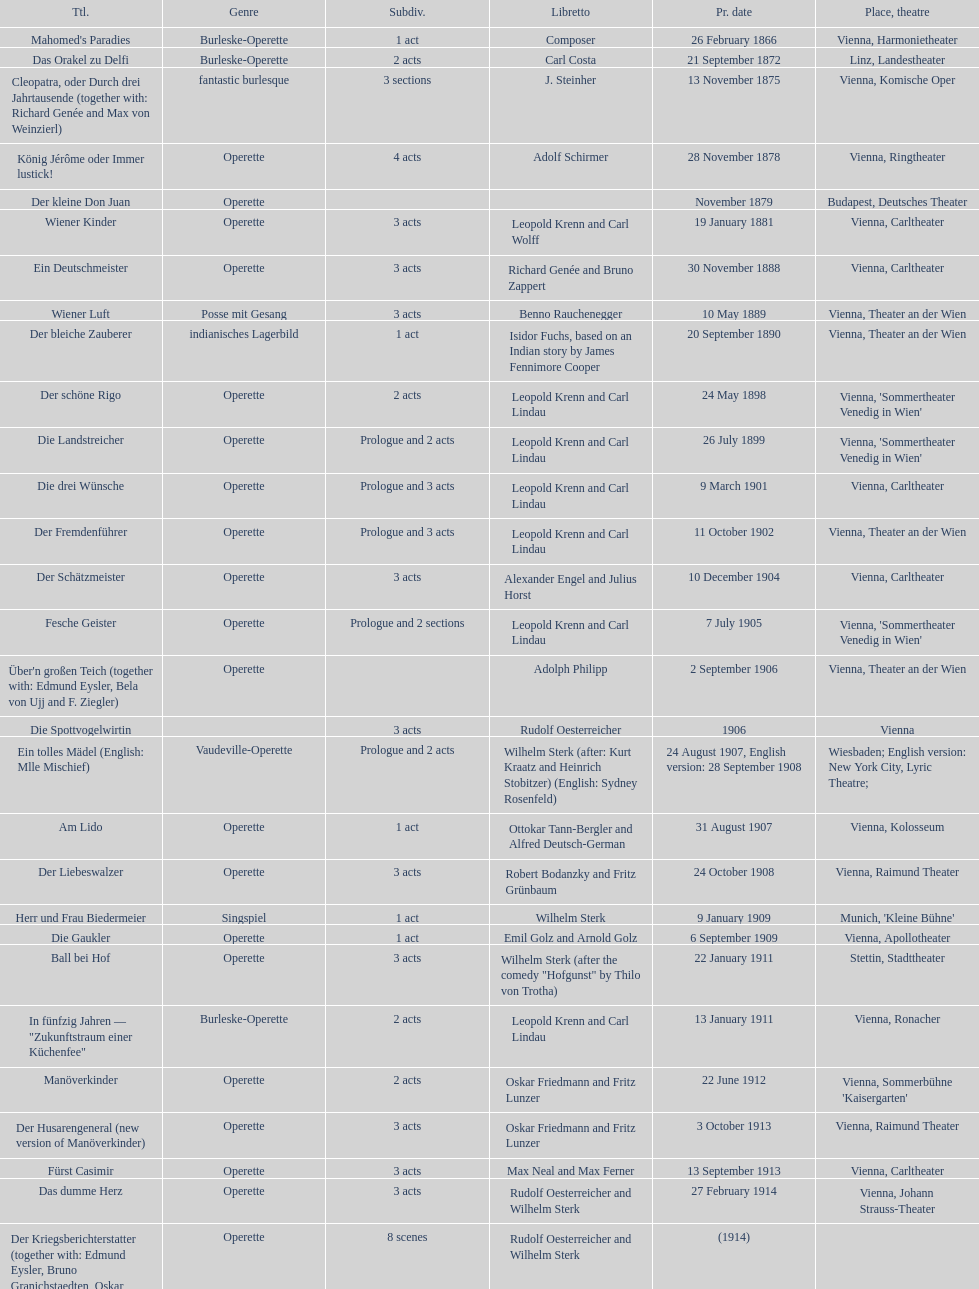Which year did he release his last operetta? 1930. 